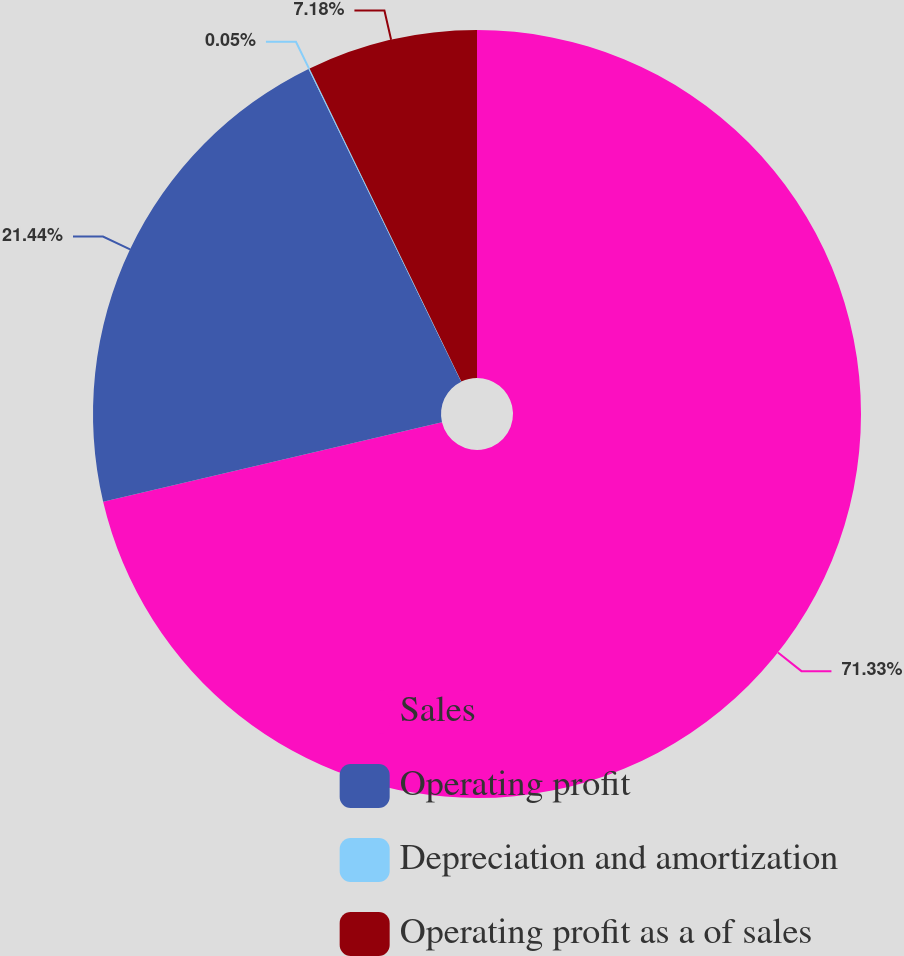Convert chart to OTSL. <chart><loc_0><loc_0><loc_500><loc_500><pie_chart><fcel>Sales<fcel>Operating profit<fcel>Depreciation and amortization<fcel>Operating profit as a of sales<nl><fcel>71.34%<fcel>21.44%<fcel>0.05%<fcel>7.18%<nl></chart> 